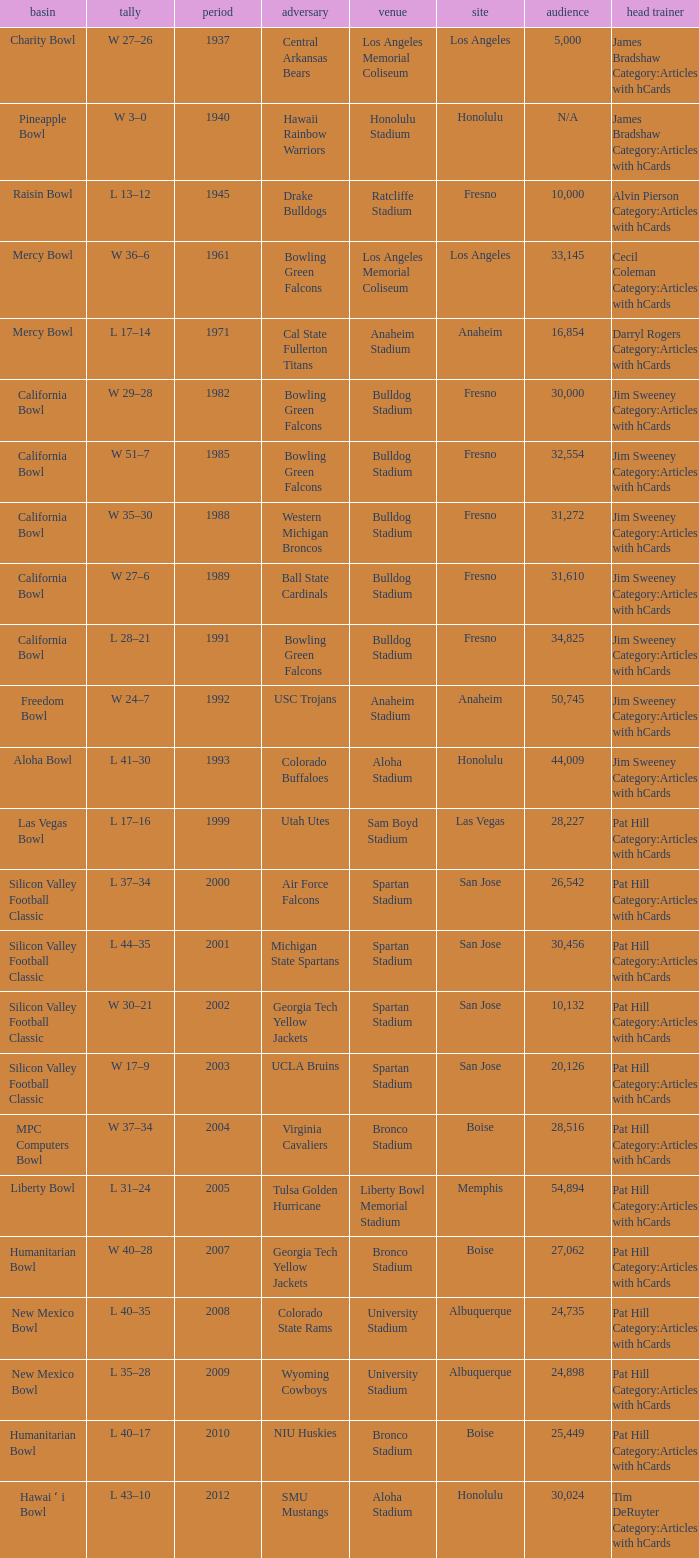Where was the California bowl played with 30,000 attending? Fresno. 